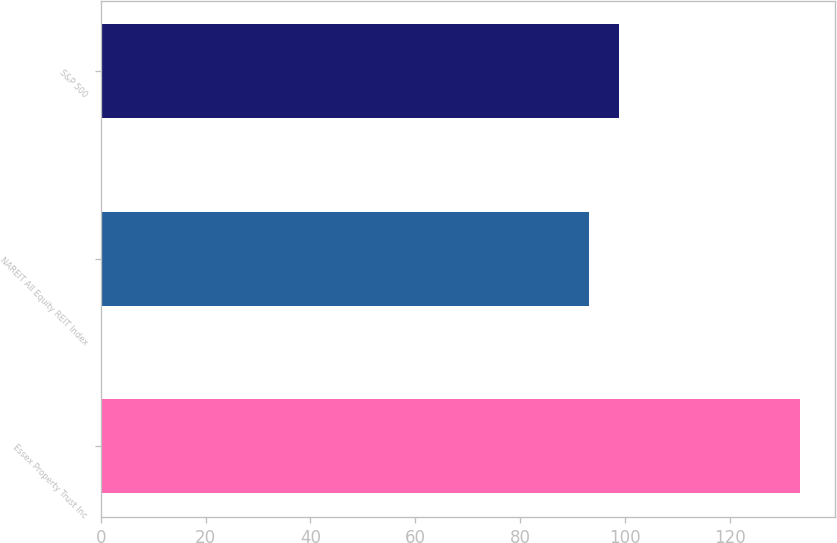Convert chart to OTSL. <chart><loc_0><loc_0><loc_500><loc_500><bar_chart><fcel>Essex Property Trust Inc<fcel>NAREIT All Equity REIT Index<fcel>S&P 500<nl><fcel>133.33<fcel>93.1<fcel>98.76<nl></chart> 